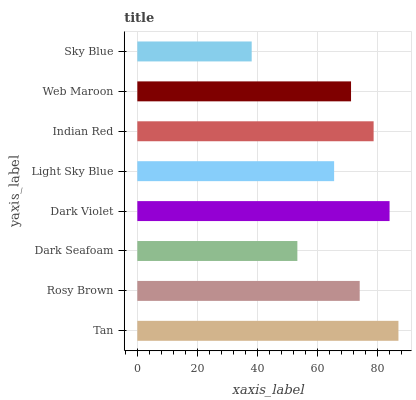Is Sky Blue the minimum?
Answer yes or no. Yes. Is Tan the maximum?
Answer yes or no. Yes. Is Rosy Brown the minimum?
Answer yes or no. No. Is Rosy Brown the maximum?
Answer yes or no. No. Is Tan greater than Rosy Brown?
Answer yes or no. Yes. Is Rosy Brown less than Tan?
Answer yes or no. Yes. Is Rosy Brown greater than Tan?
Answer yes or no. No. Is Tan less than Rosy Brown?
Answer yes or no. No. Is Rosy Brown the high median?
Answer yes or no. Yes. Is Web Maroon the low median?
Answer yes or no. Yes. Is Light Sky Blue the high median?
Answer yes or no. No. Is Indian Red the low median?
Answer yes or no. No. 